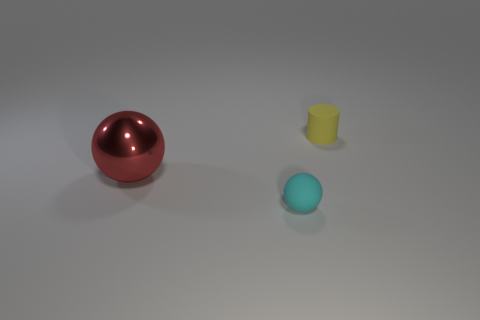Add 1 cyan rubber things. How many objects exist? 4 Subtract all balls. How many objects are left? 1 Subtract 0 green cubes. How many objects are left? 3 Subtract all metal cylinders. Subtract all yellow things. How many objects are left? 2 Add 1 cyan things. How many cyan things are left? 2 Add 2 big purple blocks. How many big purple blocks exist? 2 